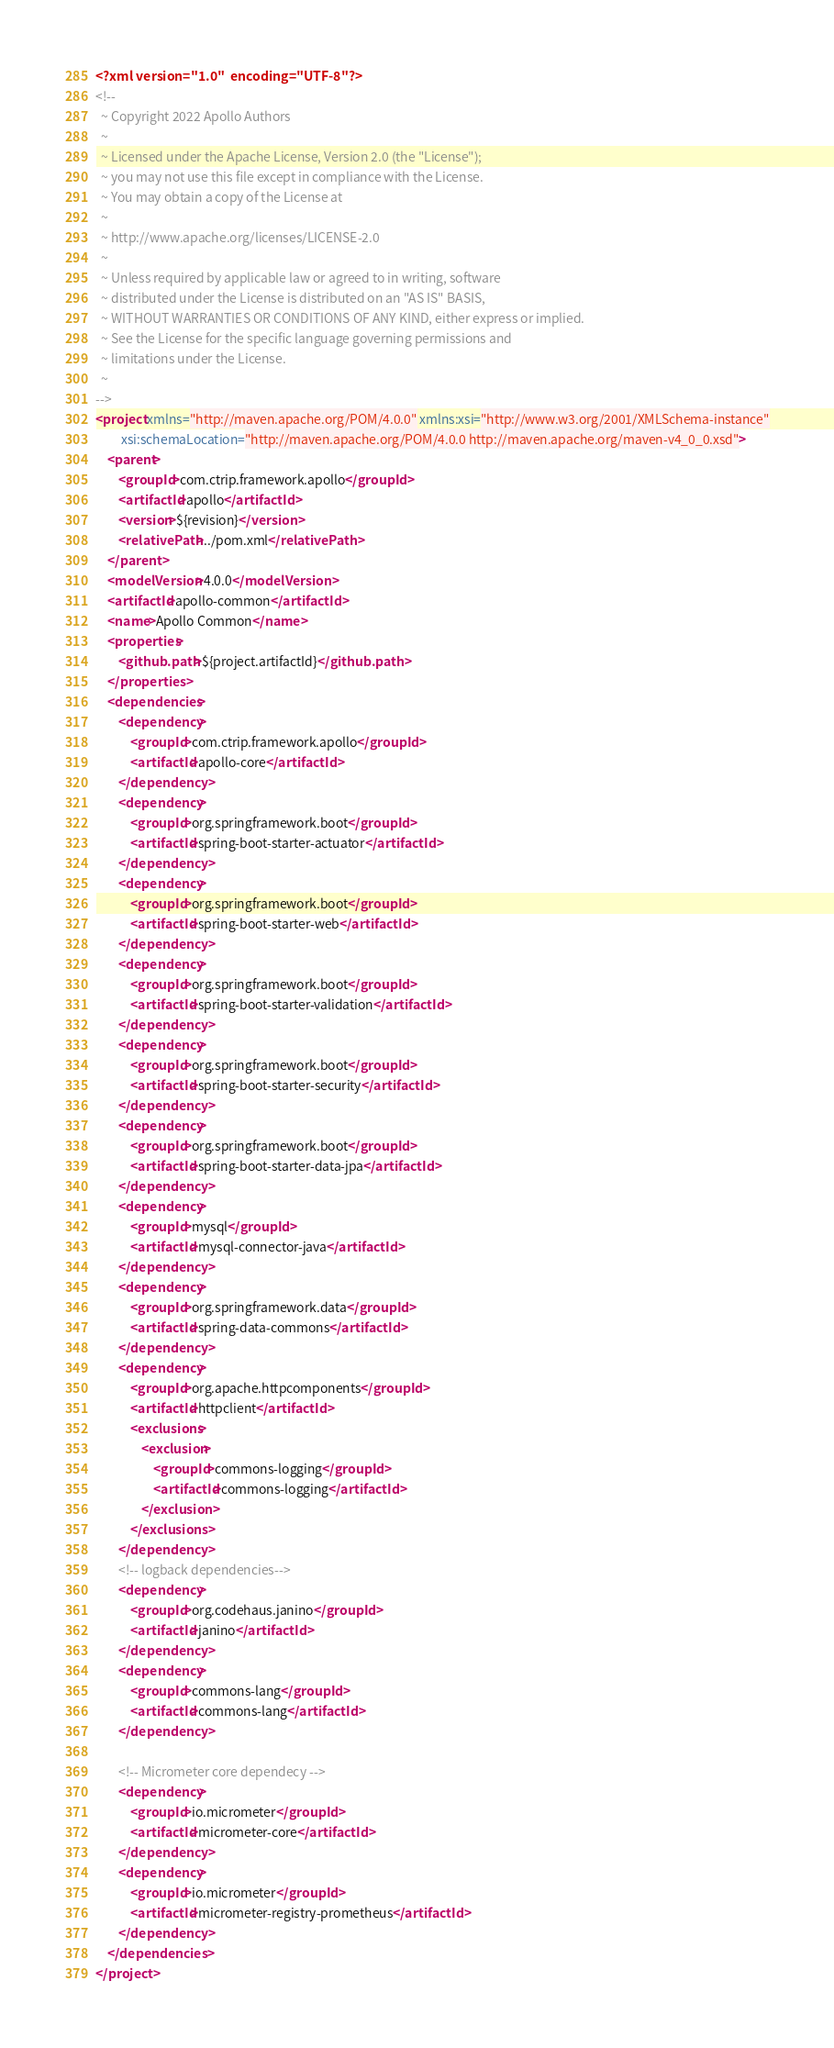<code> <loc_0><loc_0><loc_500><loc_500><_XML_><?xml version="1.0"  encoding="UTF-8"?>
<!--
  ~ Copyright 2022 Apollo Authors
  ~
  ~ Licensed under the Apache License, Version 2.0 (the "License");
  ~ you may not use this file except in compliance with the License.
  ~ You may obtain a copy of the License at
  ~
  ~ http://www.apache.org/licenses/LICENSE-2.0
  ~
  ~ Unless required by applicable law or agreed to in writing, software
  ~ distributed under the License is distributed on an "AS IS" BASIS,
  ~ WITHOUT WARRANTIES OR CONDITIONS OF ANY KIND, either express or implied.
  ~ See the License for the specific language governing permissions and
  ~ limitations under the License.
  ~
-->
<project xmlns="http://maven.apache.org/POM/4.0.0" xmlns:xsi="http://www.w3.org/2001/XMLSchema-instance"
         xsi:schemaLocation="http://maven.apache.org/POM/4.0.0 http://maven.apache.org/maven-v4_0_0.xsd">
    <parent>
        <groupId>com.ctrip.framework.apollo</groupId>
        <artifactId>apollo</artifactId>
        <version>${revision}</version>
        <relativePath>../pom.xml</relativePath>
    </parent>
    <modelVersion>4.0.0</modelVersion>
    <artifactId>apollo-common</artifactId>
    <name>Apollo Common</name>
    <properties>
        <github.path>${project.artifactId}</github.path>
    </properties>
    <dependencies>
        <dependency>
            <groupId>com.ctrip.framework.apollo</groupId>
            <artifactId>apollo-core</artifactId>
        </dependency>
        <dependency>
            <groupId>org.springframework.boot</groupId>
            <artifactId>spring-boot-starter-actuator</artifactId>
        </dependency>
        <dependency>
            <groupId>org.springframework.boot</groupId>
            <artifactId>spring-boot-starter-web</artifactId>
        </dependency>
        <dependency>
            <groupId>org.springframework.boot</groupId>
            <artifactId>spring-boot-starter-validation</artifactId>
        </dependency>
        <dependency>
            <groupId>org.springframework.boot</groupId>
            <artifactId>spring-boot-starter-security</artifactId>
        </dependency>
        <dependency>
            <groupId>org.springframework.boot</groupId>
            <artifactId>spring-boot-starter-data-jpa</artifactId>
        </dependency>
        <dependency>
            <groupId>mysql</groupId>
            <artifactId>mysql-connector-java</artifactId>
        </dependency>
        <dependency>
            <groupId>org.springframework.data</groupId>
            <artifactId>spring-data-commons</artifactId>
        </dependency>
        <dependency>
            <groupId>org.apache.httpcomponents</groupId>
            <artifactId>httpclient</artifactId>
            <exclusions>
                <exclusion>
                    <groupId>commons-logging</groupId>
                    <artifactId>commons-logging</artifactId>
                </exclusion>
            </exclusions>
        </dependency>
        <!-- logback dependencies-->
        <dependency>
            <groupId>org.codehaus.janino</groupId>
            <artifactId>janino</artifactId>
        </dependency>
        <dependency>
            <groupId>commons-lang</groupId>
            <artifactId>commons-lang</artifactId>
        </dependency>

        <!-- Micrometer core dependecy -->
        <dependency>
            <groupId>io.micrometer</groupId>
            <artifactId>micrometer-core</artifactId>
        </dependency>
        <dependency>
            <groupId>io.micrometer</groupId>
            <artifactId>micrometer-registry-prometheus</artifactId>
        </dependency>
    </dependencies>
</project>
</code> 